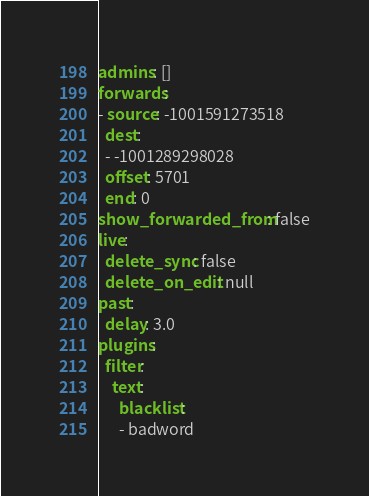<code> <loc_0><loc_0><loc_500><loc_500><_YAML_>admins: []
forwards:
- source: -1001591273518
  dest:
  - -1001289298028
  offset: 5701
  end: 0
show_forwarded_from: false
live:
  delete_sync: false
  delete_on_edit: null
past:
  delay: 3.0
plugins:
  filter:
    text:
      blacklist:
      - badword
</code> 